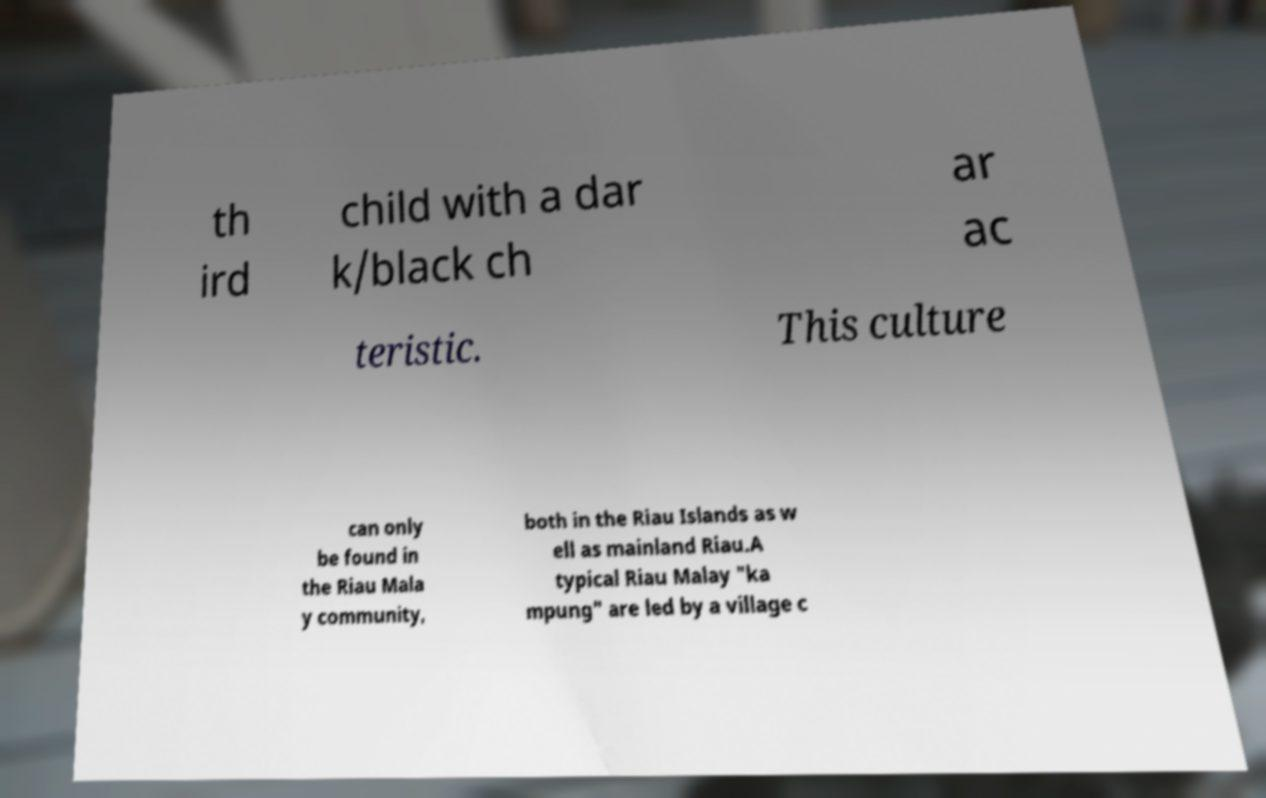Could you assist in decoding the text presented in this image and type it out clearly? th ird child with a dar k/black ch ar ac teristic. This culture can only be found in the Riau Mala y community, both in the Riau Islands as w ell as mainland Riau.A typical Riau Malay "ka mpung" are led by a village c 